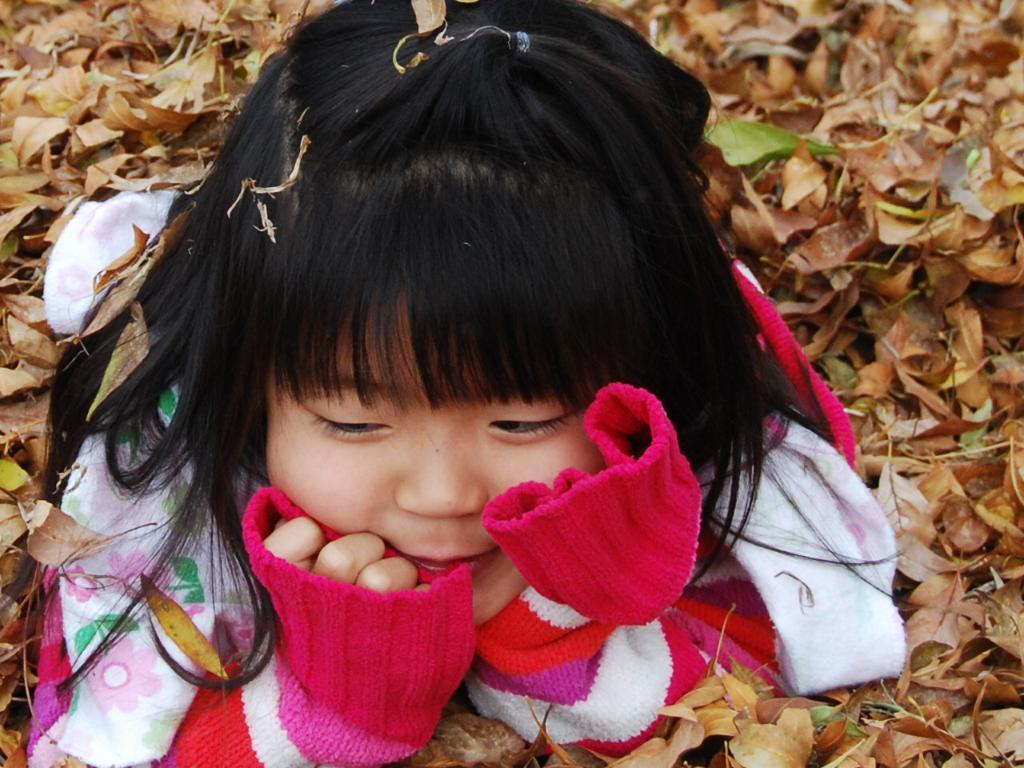Who is the main subject in the image? There is a girl in the image. What is the girl doing in the image? The girl is lying on dried leaves. What is the ground made of in the image? There are dried leaves on the ground in the image. What type of potato can be seen in the image? There is no potato present in the image. Can you tell me how the girl is swimming in the image? The girl is not swimming in the image; she is lying on dried leaves. 